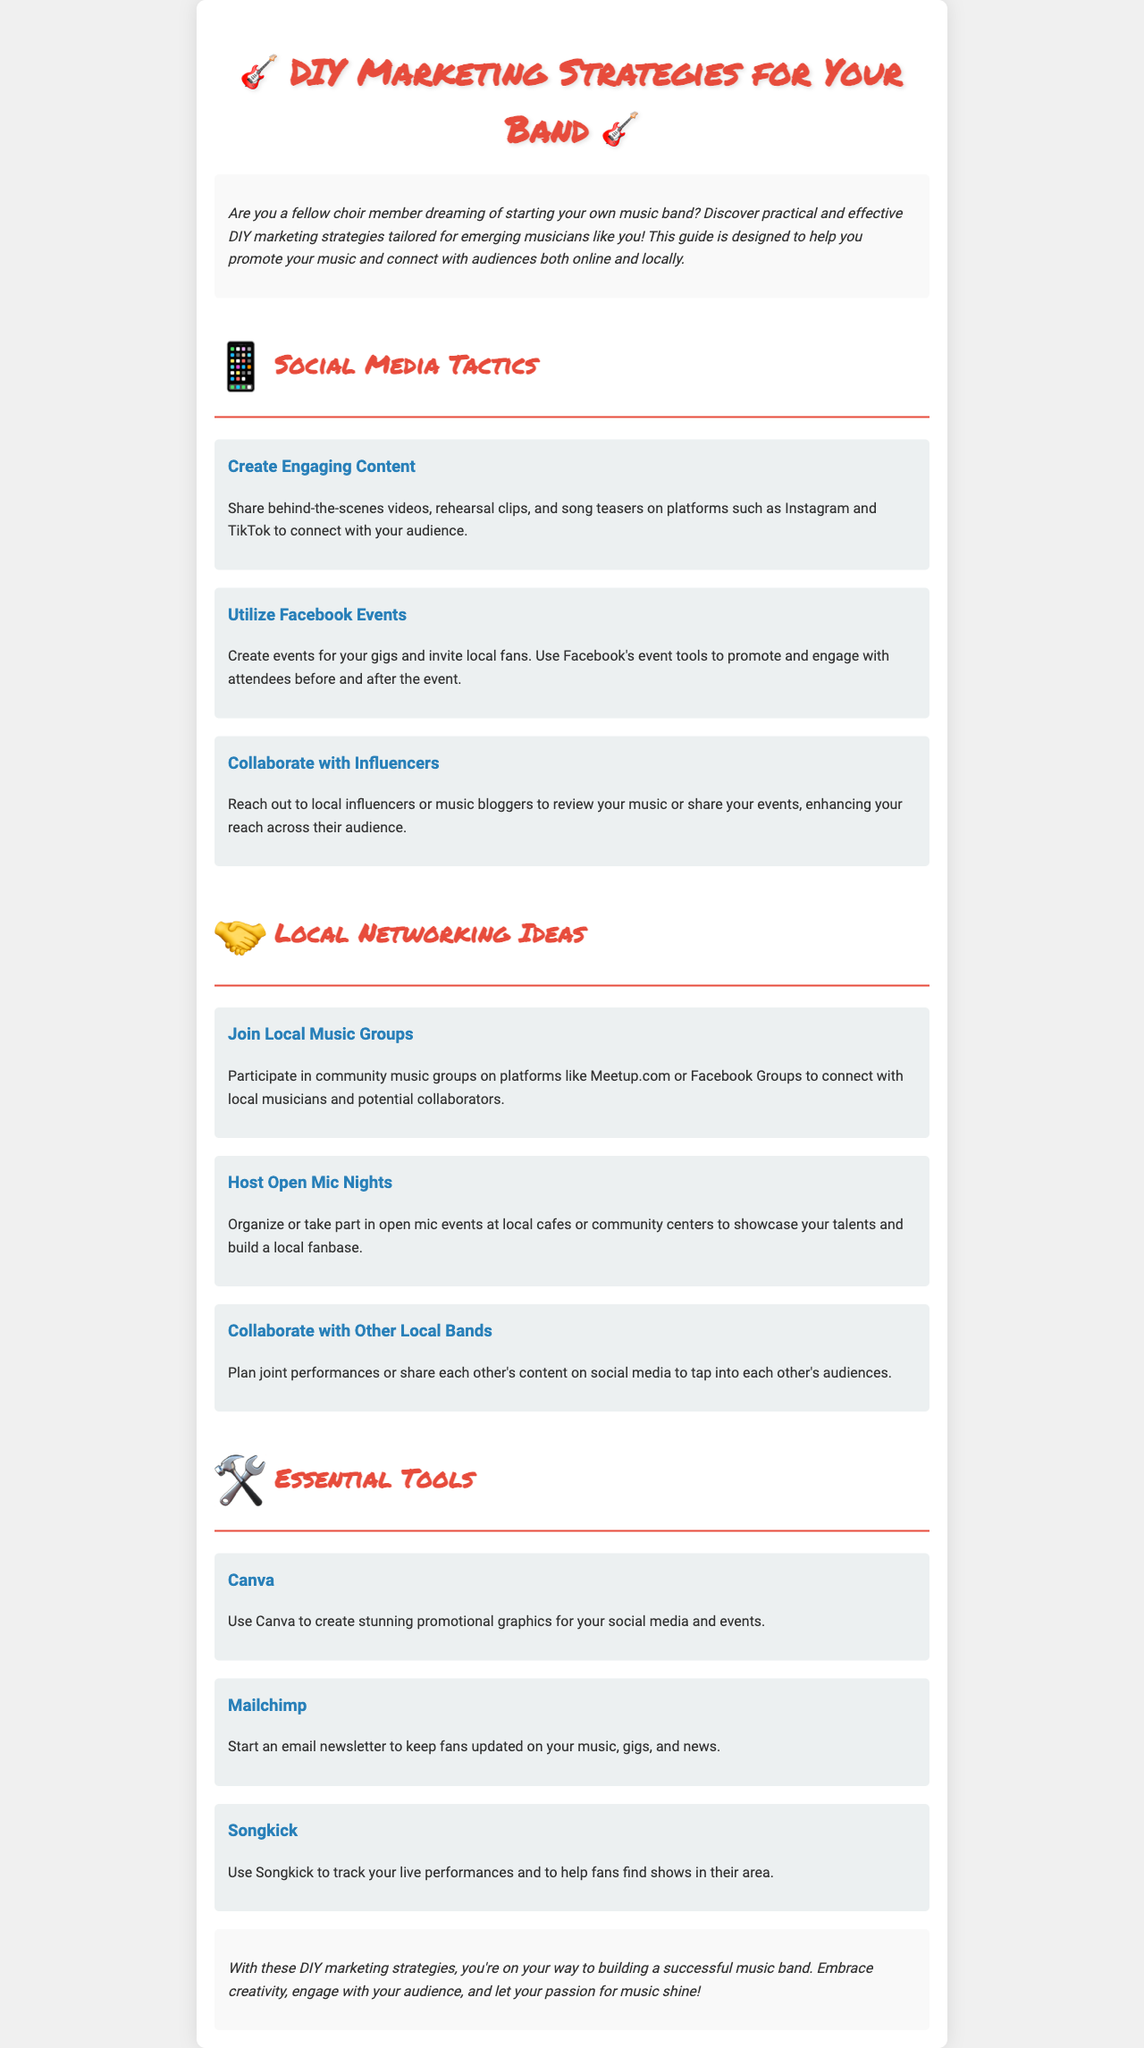What are some social media platforms recommended for sharing content? The document suggests sharing content on Instagram and TikTok.
Answer: Instagram and TikTok What is one way to promote gigs on Facebook? The document mentions creating events for your gigs and inviting local fans.
Answer: Create events What should you use Canva for? According to the document, Canva is used to create stunning promotional graphics for social media and events.
Answer: Promotional graphics How many strategies are listed under Social Media Tactics? The document lists three strategies under Social Media Tactics.
Answer: Three What is one benefit of collaborating with local bands? The document states that collaborating with other local bands can help tap into each other's audiences.
Answer: Tap into audiences What is a recommended tool for sending email newsletters? The document recommends using Mailchimp for email newsletters.
Answer: Mailchimp What type of events can you host to showcase your talents? The document suggests organizing or participating in open mic events.
Answer: Open mic events What color is used for the h1 title? The document specifies that the color used for the h1 title is #e74c3c.
Answer: #e74c3c 